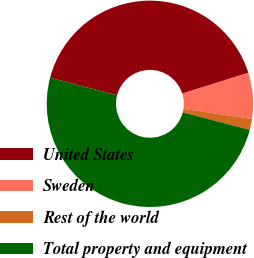<chart> <loc_0><loc_0><loc_500><loc_500><pie_chart><fcel>United States<fcel>Sweden<fcel>Rest of the world<fcel>Total property and equipment<nl><fcel>41.08%<fcel>7.2%<fcel>1.72%<fcel>50.0%<nl></chart> 